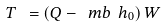<formula> <loc_0><loc_0><loc_500><loc_500>T \ = \left ( Q - \ m b \ h _ { 0 } \right ) W</formula> 